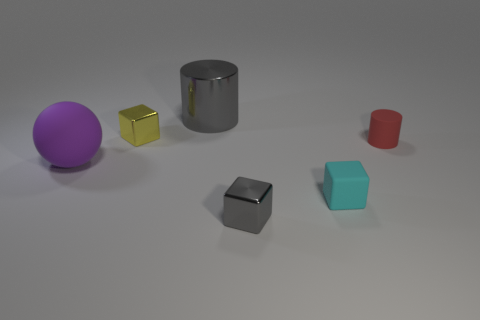Are the tiny object that is to the left of the gray cube and the gray thing on the left side of the small gray object made of the same material? Based on the image, it’s not possible to definitively determine whether the tiny object to the left of the gray cube and the gray object on the left side are made of the same material solely by their appearance. Both objects exhibit a gray color and matte surface, suggesting they could be similar, but without more context or information about the objects' composition, one cannot be certain. 